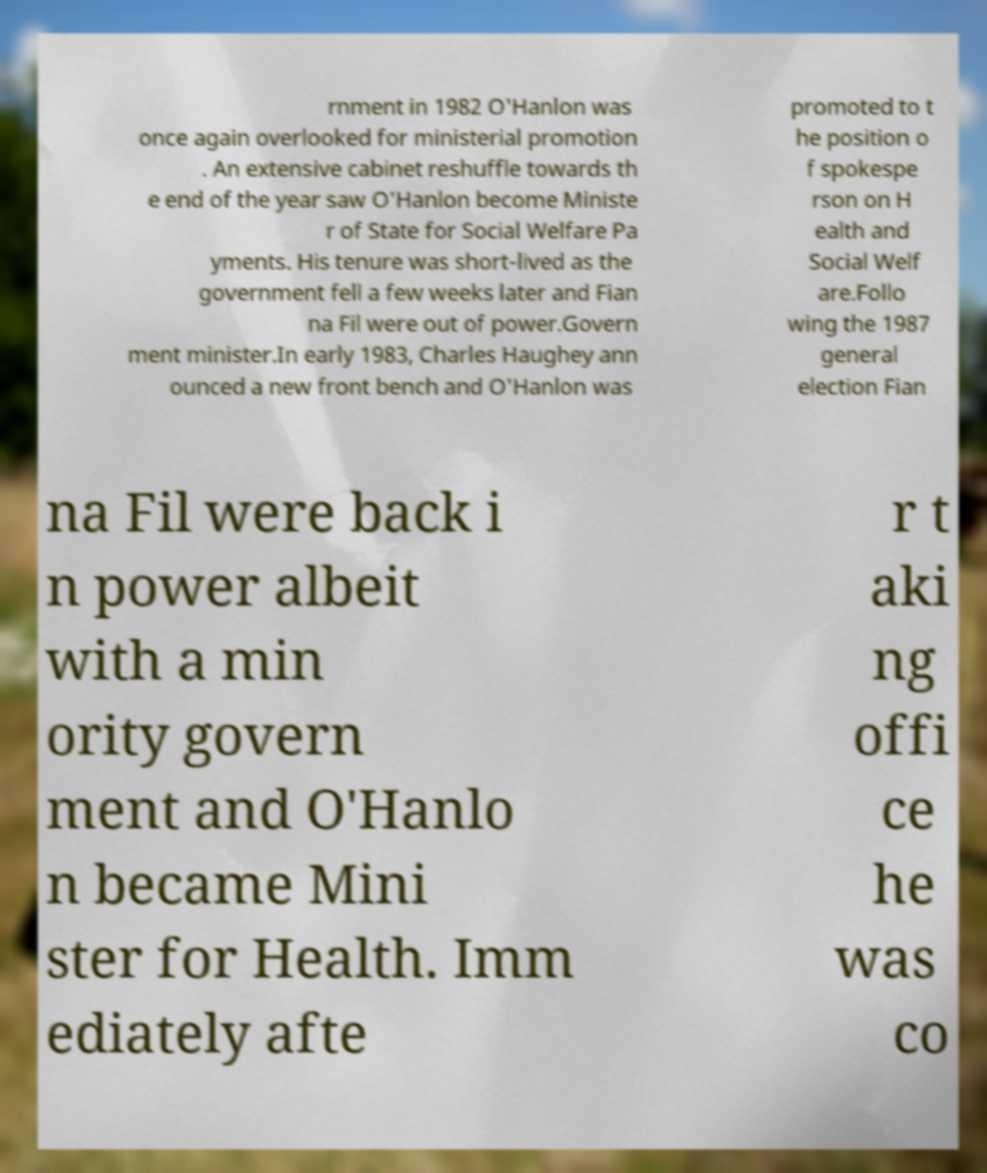Can you accurately transcribe the text from the provided image for me? rnment in 1982 O'Hanlon was once again overlooked for ministerial promotion . An extensive cabinet reshuffle towards th e end of the year saw O'Hanlon become Ministe r of State for Social Welfare Pa yments. His tenure was short-lived as the government fell a few weeks later and Fian na Fil were out of power.Govern ment minister.In early 1983, Charles Haughey ann ounced a new front bench and O'Hanlon was promoted to t he position o f spokespe rson on H ealth and Social Welf are.Follo wing the 1987 general election Fian na Fil were back i n power albeit with a min ority govern ment and O'Hanlo n became Mini ster for Health. Imm ediately afte r t aki ng offi ce he was co 